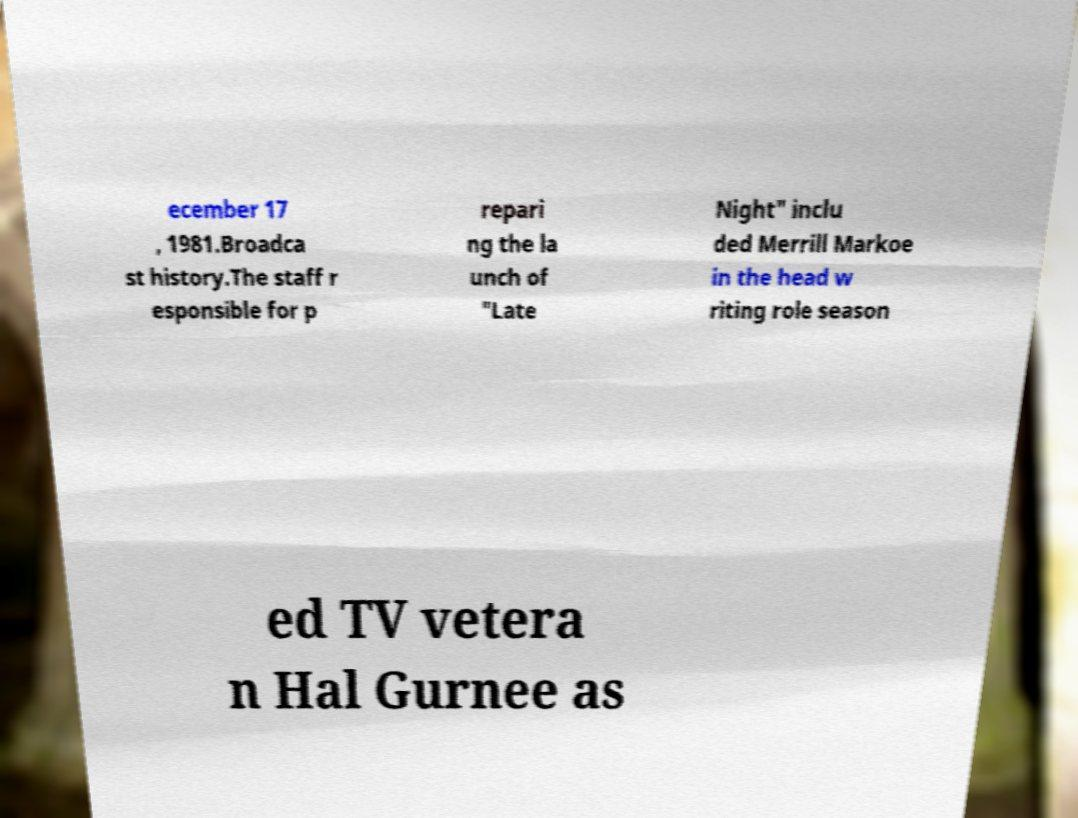Can you accurately transcribe the text from the provided image for me? ecember 17 , 1981.Broadca st history.The staff r esponsible for p repari ng the la unch of "Late Night" inclu ded Merrill Markoe in the head w riting role season ed TV vetera n Hal Gurnee as 